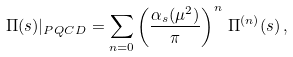<formula> <loc_0><loc_0><loc_500><loc_500>\Pi ( s ) | _ { P Q C D } = \sum _ { n = 0 } \left ( \frac { \alpha _ { s } ( \mu ^ { 2 } ) } { \pi } \right ) ^ { n } \, \Pi ^ { ( n ) } ( s ) \, ,</formula> 